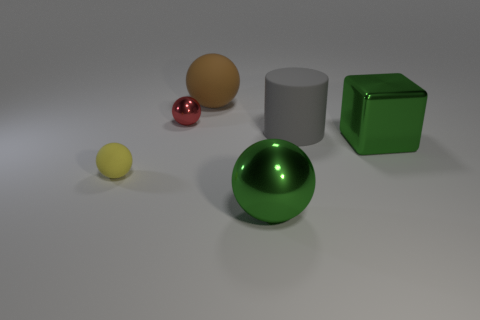Is there a big ball that has the same color as the large cube?
Provide a succinct answer. Yes. Are any red metallic things visible?
Keep it short and to the point. Yes. Is the material of the big green thing on the left side of the gray object the same as the big gray thing?
Give a very brief answer. No. What size is the thing that is the same color as the metal block?
Your response must be concise. Large. What number of yellow matte spheres have the same size as the green block?
Ensure brevity in your answer.  0. Are there an equal number of large matte spheres that are in front of the gray matte cylinder and big gray rubber cylinders?
Offer a terse response. No. What number of things are to the right of the big brown sphere and behind the yellow rubber ball?
Offer a terse response. 2. The other sphere that is made of the same material as the red sphere is what size?
Your answer should be compact. Large. How many brown objects have the same shape as the small red object?
Your answer should be very brief. 1. Is the number of balls that are behind the brown sphere greater than the number of cyan metal blocks?
Your answer should be very brief. No. 